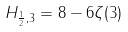Convert formula to latex. <formula><loc_0><loc_0><loc_500><loc_500>H _ { { \frac { 1 } { 2 } } , 3 } = 8 - 6 \zeta ( 3 )</formula> 